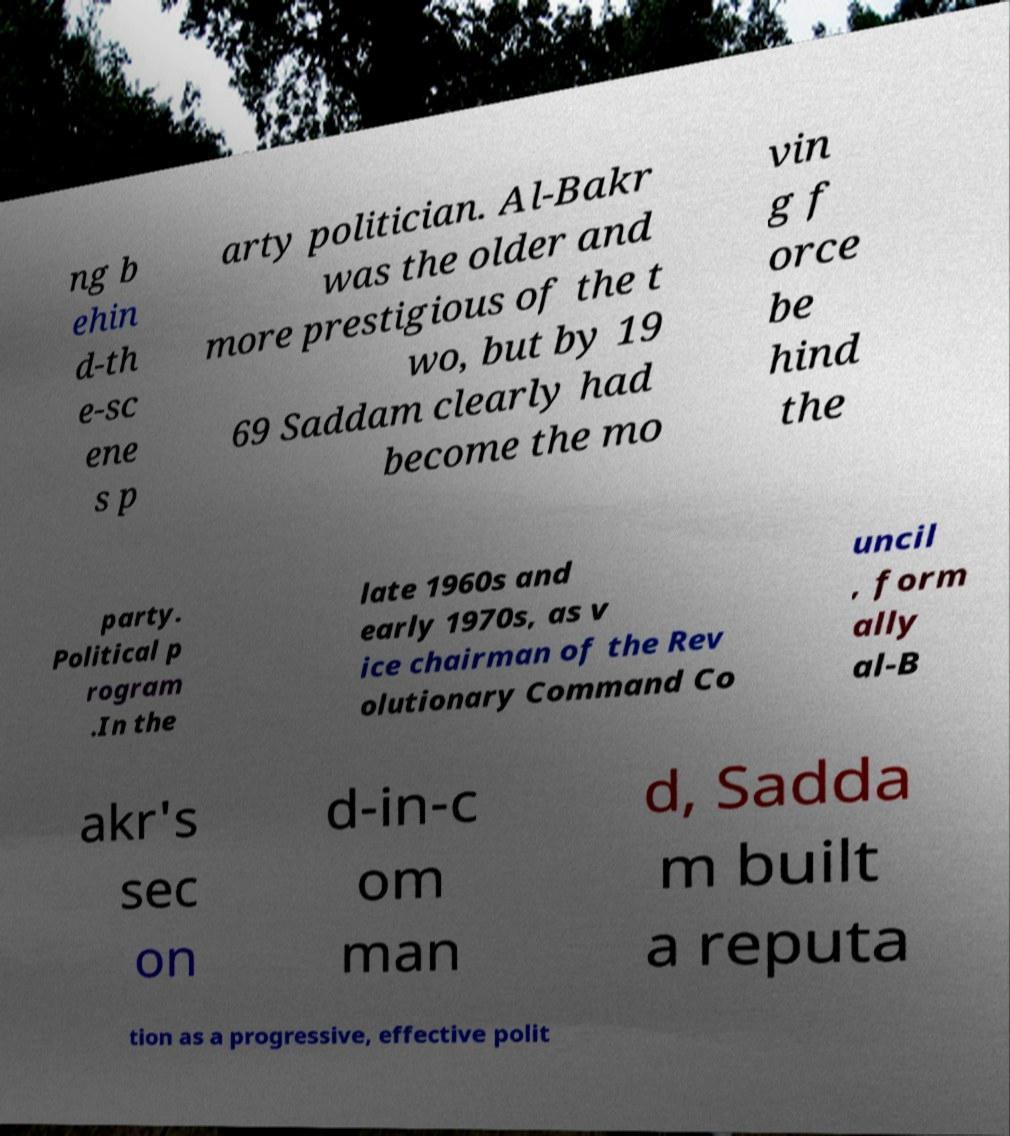Please identify and transcribe the text found in this image. ng b ehin d-th e-sc ene s p arty politician. Al-Bakr was the older and more prestigious of the t wo, but by 19 69 Saddam clearly had become the mo vin g f orce be hind the party. Political p rogram .In the late 1960s and early 1970s, as v ice chairman of the Rev olutionary Command Co uncil , form ally al-B akr's sec on d-in-c om man d, Sadda m built a reputa tion as a progressive, effective polit 